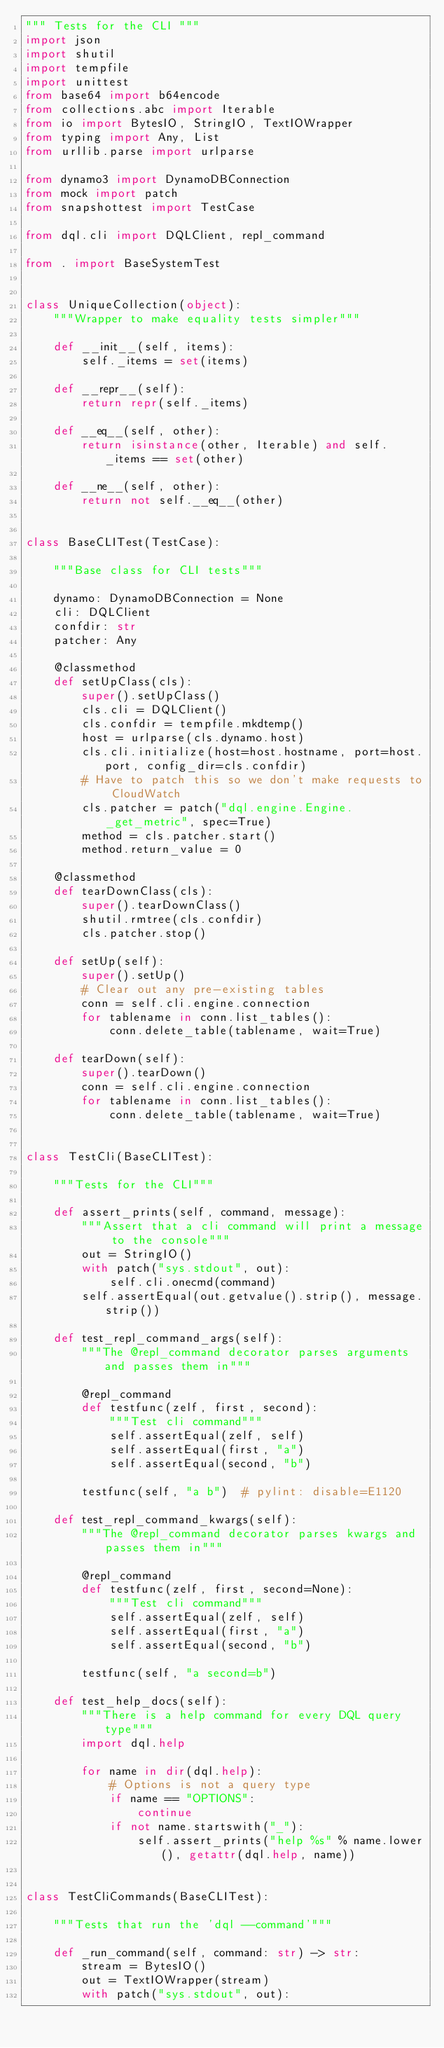<code> <loc_0><loc_0><loc_500><loc_500><_Python_>""" Tests for the CLI """
import json
import shutil
import tempfile
import unittest
from base64 import b64encode
from collections.abc import Iterable
from io import BytesIO, StringIO, TextIOWrapper
from typing import Any, List
from urllib.parse import urlparse

from dynamo3 import DynamoDBConnection
from mock import patch
from snapshottest import TestCase

from dql.cli import DQLClient, repl_command

from . import BaseSystemTest


class UniqueCollection(object):
    """Wrapper to make equality tests simpler"""

    def __init__(self, items):
        self._items = set(items)

    def __repr__(self):
        return repr(self._items)

    def __eq__(self, other):
        return isinstance(other, Iterable) and self._items == set(other)

    def __ne__(self, other):
        return not self.__eq__(other)


class BaseCLITest(TestCase):

    """Base class for CLI tests"""

    dynamo: DynamoDBConnection = None
    cli: DQLClient
    confdir: str
    patcher: Any

    @classmethod
    def setUpClass(cls):
        super().setUpClass()
        cls.cli = DQLClient()
        cls.confdir = tempfile.mkdtemp()
        host = urlparse(cls.dynamo.host)
        cls.cli.initialize(host=host.hostname, port=host.port, config_dir=cls.confdir)
        # Have to patch this so we don't make requests to CloudWatch
        cls.patcher = patch("dql.engine.Engine._get_metric", spec=True)
        method = cls.patcher.start()
        method.return_value = 0

    @classmethod
    def tearDownClass(cls):
        super().tearDownClass()
        shutil.rmtree(cls.confdir)
        cls.patcher.stop()

    def setUp(self):
        super().setUp()
        # Clear out any pre-existing tables
        conn = self.cli.engine.connection
        for tablename in conn.list_tables():
            conn.delete_table(tablename, wait=True)

    def tearDown(self):
        super().tearDown()
        conn = self.cli.engine.connection
        for tablename in conn.list_tables():
            conn.delete_table(tablename, wait=True)


class TestCli(BaseCLITest):

    """Tests for the CLI"""

    def assert_prints(self, command, message):
        """Assert that a cli command will print a message to the console"""
        out = StringIO()
        with patch("sys.stdout", out):
            self.cli.onecmd(command)
        self.assertEqual(out.getvalue().strip(), message.strip())

    def test_repl_command_args(self):
        """The @repl_command decorator parses arguments and passes them in"""

        @repl_command
        def testfunc(zelf, first, second):
            """Test cli command"""
            self.assertEqual(zelf, self)
            self.assertEqual(first, "a")
            self.assertEqual(second, "b")

        testfunc(self, "a b")  # pylint: disable=E1120

    def test_repl_command_kwargs(self):
        """The @repl_command decorator parses kwargs and passes them in"""

        @repl_command
        def testfunc(zelf, first, second=None):
            """Test cli command"""
            self.assertEqual(zelf, self)
            self.assertEqual(first, "a")
            self.assertEqual(second, "b")

        testfunc(self, "a second=b")

    def test_help_docs(self):
        """There is a help command for every DQL query type"""
        import dql.help

        for name in dir(dql.help):
            # Options is not a query type
            if name == "OPTIONS":
                continue
            if not name.startswith("_"):
                self.assert_prints("help %s" % name.lower(), getattr(dql.help, name))


class TestCliCommands(BaseCLITest):

    """Tests that run the 'dql --command'"""

    def _run_command(self, command: str) -> str:
        stream = BytesIO()
        out = TextIOWrapper(stream)
        with patch("sys.stdout", out):</code> 